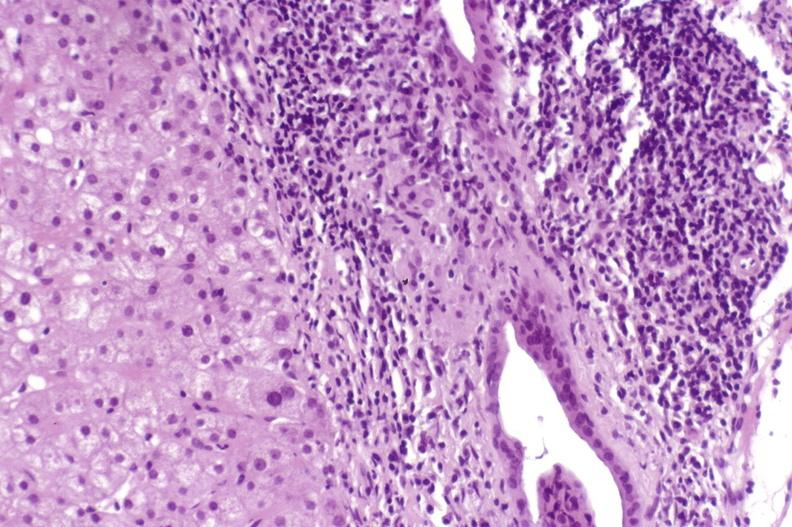what is present?
Answer the question using a single word or phrase. Liver 